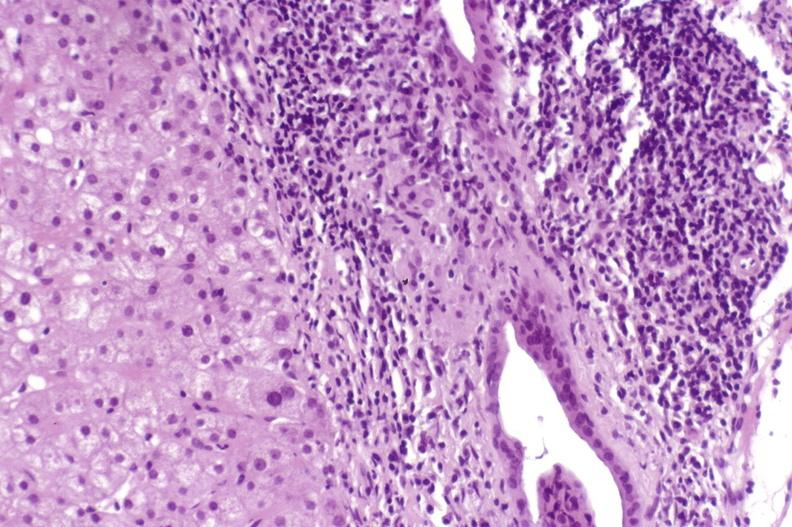what is present?
Answer the question using a single word or phrase. Liver 